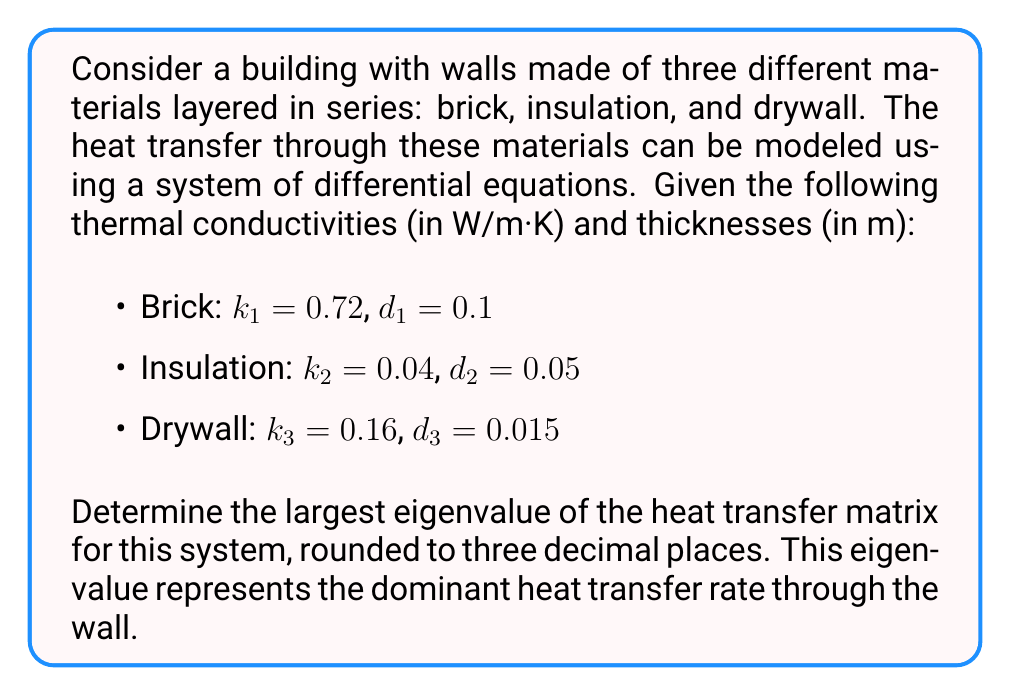What is the answer to this math problem? To solve this problem, we'll follow these steps:

1) First, we need to set up the heat transfer matrix. For a system with three layers in series, the matrix $A$ is given by:

   $$A = \begin{bmatrix}
   -\frac{k_1+k_2}{d_1d_2} & \frac{k_2}{d_1d_2} & 0 \\
   \frac{k_2}{d_1d_2} & -\frac{k_2+k_3}{d_2d_3} & \frac{k_3}{d_2d_3} \\
   0 & \frac{k_3}{d_2d_3} & -\frac{k_3}{d_2d_3}
   \end{bmatrix}$$

2) Let's calculate each term:

   $\frac{k_1+k_2}{d_1d_2} = \frac{0.72 + 0.04}{0.1 \cdot 0.05} = 152$
   $\frac{k_2}{d_1d_2} = \frac{0.04}{0.1 \cdot 0.05} = 8$
   $\frac{k_2+k_3}{d_2d_3} = \frac{0.04 + 0.16}{0.05 \cdot 0.015} = 266.667$
   $\frac{k_3}{d_2d_3} = \frac{0.16}{0.05 \cdot 0.015} = 213.333$

3) Substituting these values into the matrix:

   $$A = \begin{bmatrix}
   -152 & 8 & 0 \\
   8 & -266.667 & 213.333 \\
   0 & 213.333 & -213.333
   \end{bmatrix}$$

4) To find the eigenvalues, we need to solve the characteristic equation:

   $det(A - \lambda I) = 0$

5) Expanding this determinant gives us a cubic equation:

   $-\lambda^3 + 632\lambda^2 - 132267\lambda + 9159111 = 0$

6) This equation can be solved numerically. Using a computer algebra system or numerical methods, we find the roots (eigenvalues) to be approximately:

   $\lambda_1 \approx -1.537$
   $\lambda_2 \approx -213.333$
   $\lambda_3 \approx -417.130$

7) The largest eigenvalue (in absolute value) is $\lambda_3 \approx -417.130$.

8) Rounding to three decimal places, we get -417.130.
Answer: -417.130 